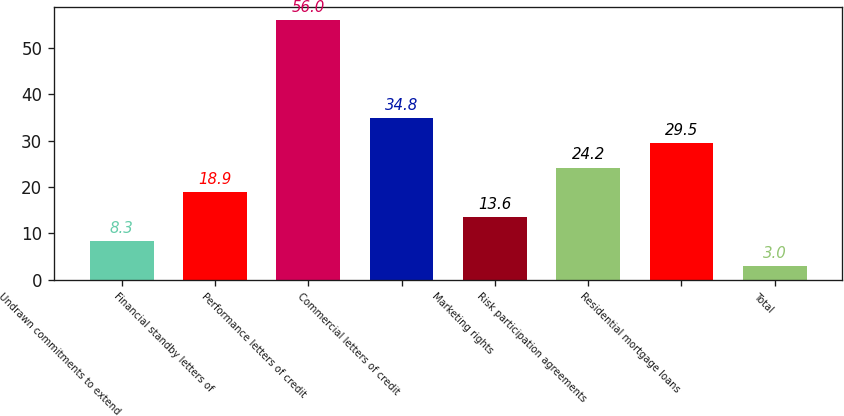Convert chart. <chart><loc_0><loc_0><loc_500><loc_500><bar_chart><fcel>Undrawn commitments to extend<fcel>Financial standby letters of<fcel>Performance letters of credit<fcel>Commercial letters of credit<fcel>Marketing rights<fcel>Risk participation agreements<fcel>Residential mortgage loans<fcel>Total<nl><fcel>8.3<fcel>18.9<fcel>56<fcel>34.8<fcel>13.6<fcel>24.2<fcel>29.5<fcel>3<nl></chart> 